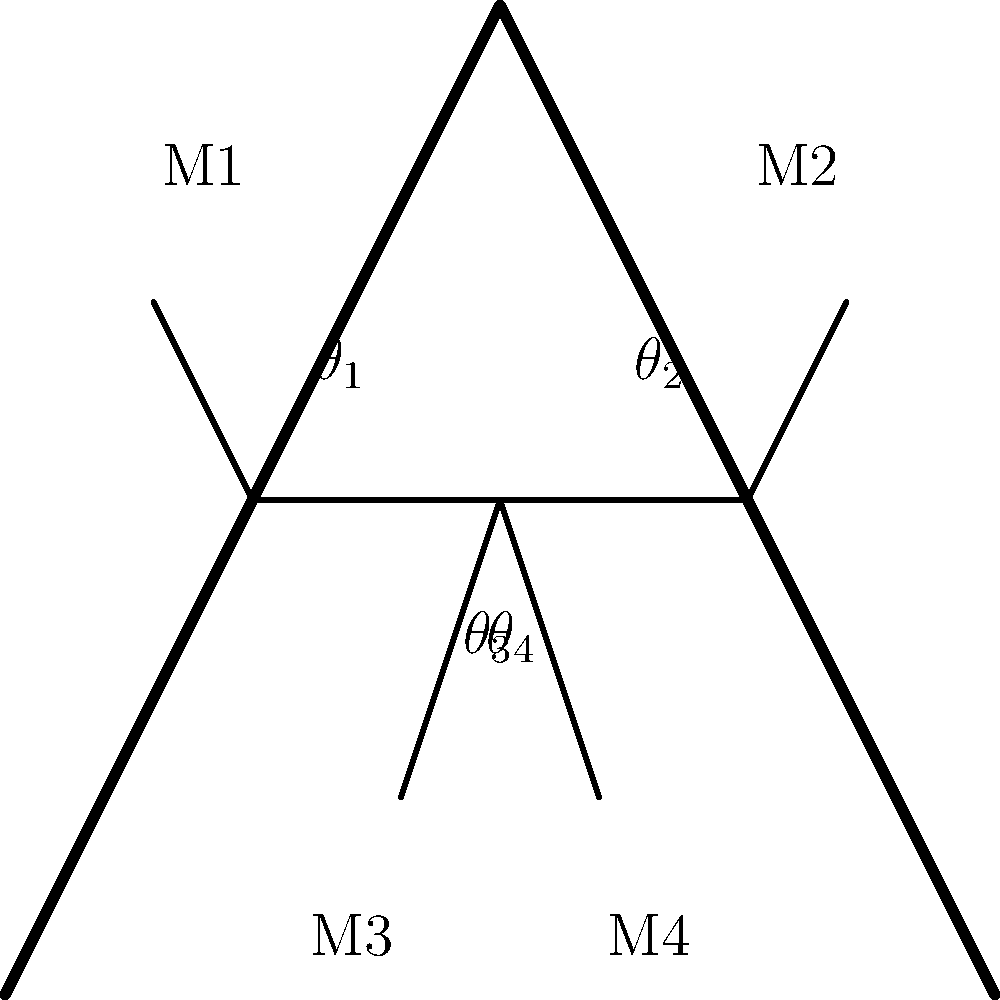In a thrilling scene from your latest treasure hunting novel, the protagonist is climbing a rope ladder on a pirate ship. Based on the biomechanical illustration provided, which muscle group (M1, M2, M3, or M4) would be most activated when the climber is pulling themselves up to the next rung, and what would be the approximate range of motion for the elbow joint ($\theta_1$ or $\theta_2$) during this action? To answer this question, we need to consider the biomechanics of climbing a rope ladder:

1. The primary action in climbing a rope ladder is pulling oneself up.

2. This upward pull primarily involves the upper body, specifically the arms and shoulders.

3. In the illustration, M1 and M2 represent the upper arm muscle groups (likely biceps and shoulders).

4. M3 and M4 represent the leg muscle groups, which are less involved in the pulling action.

5. The elbow joint (represented by $\theta_1$ and $\theta_2$) is crucial in the pulling motion.

6. When pulling up, the elbow flexes (bends), bringing the hand closer to the shoulder.

7. The muscle group most activated during this pull-up motion would be the biceps (M1 and M2).

8. The range of motion for the elbow joint during a pull-up typically varies from about 0° (fully extended) to 130-150° (fully flexed).

Therefore, the most activated muscle group would be M1 and M2 (representing the biceps), and the approximate range of motion for the elbow joint ($\theta_1$ or $\theta_2$) would be from 0° to 130-150°.
Answer: M1 and M2; 0° to 130-150° 